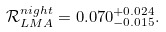Convert formula to latex. <formula><loc_0><loc_0><loc_500><loc_500>\mathcal { R } _ { L M A } ^ { n i g h t } = 0 . 0 7 0 ^ { + 0 . 0 2 4 } _ { - 0 . 0 1 5 } .</formula> 